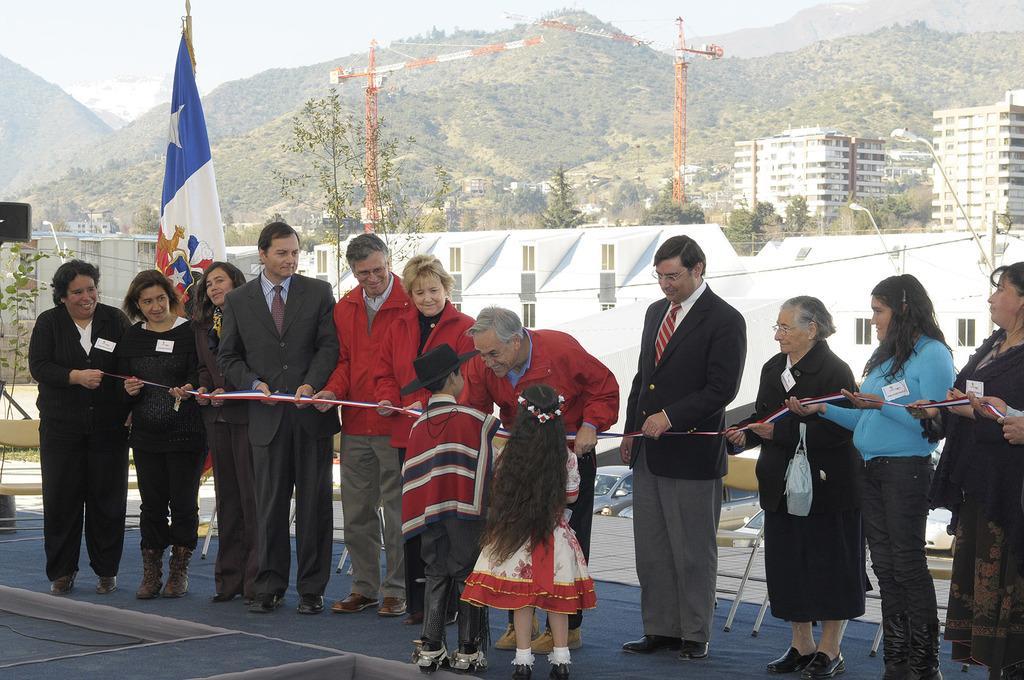Could you give a brief overview of what you see in this image? In this image I can see the group of people standing and wearing the different color dresses. I can see one person is wearing the hat and these people are holding the ribbon. In the background I can see the flag and the wall. I can also see the crane, many buildings, trees, mountains and the sky. 